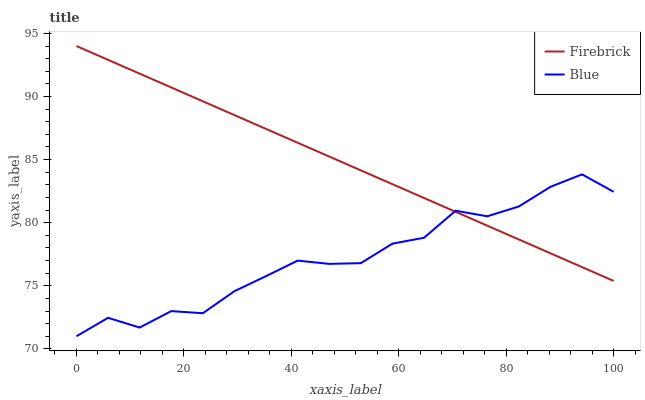Does Blue have the minimum area under the curve?
Answer yes or no. Yes. Does Firebrick have the maximum area under the curve?
Answer yes or no. Yes. Does Firebrick have the minimum area under the curve?
Answer yes or no. No. Is Firebrick the smoothest?
Answer yes or no. Yes. Is Blue the roughest?
Answer yes or no. Yes. Is Firebrick the roughest?
Answer yes or no. No. Does Blue have the lowest value?
Answer yes or no. Yes. Does Firebrick have the lowest value?
Answer yes or no. No. Does Firebrick have the highest value?
Answer yes or no. Yes. Does Blue intersect Firebrick?
Answer yes or no. Yes. Is Blue less than Firebrick?
Answer yes or no. No. Is Blue greater than Firebrick?
Answer yes or no. No. 